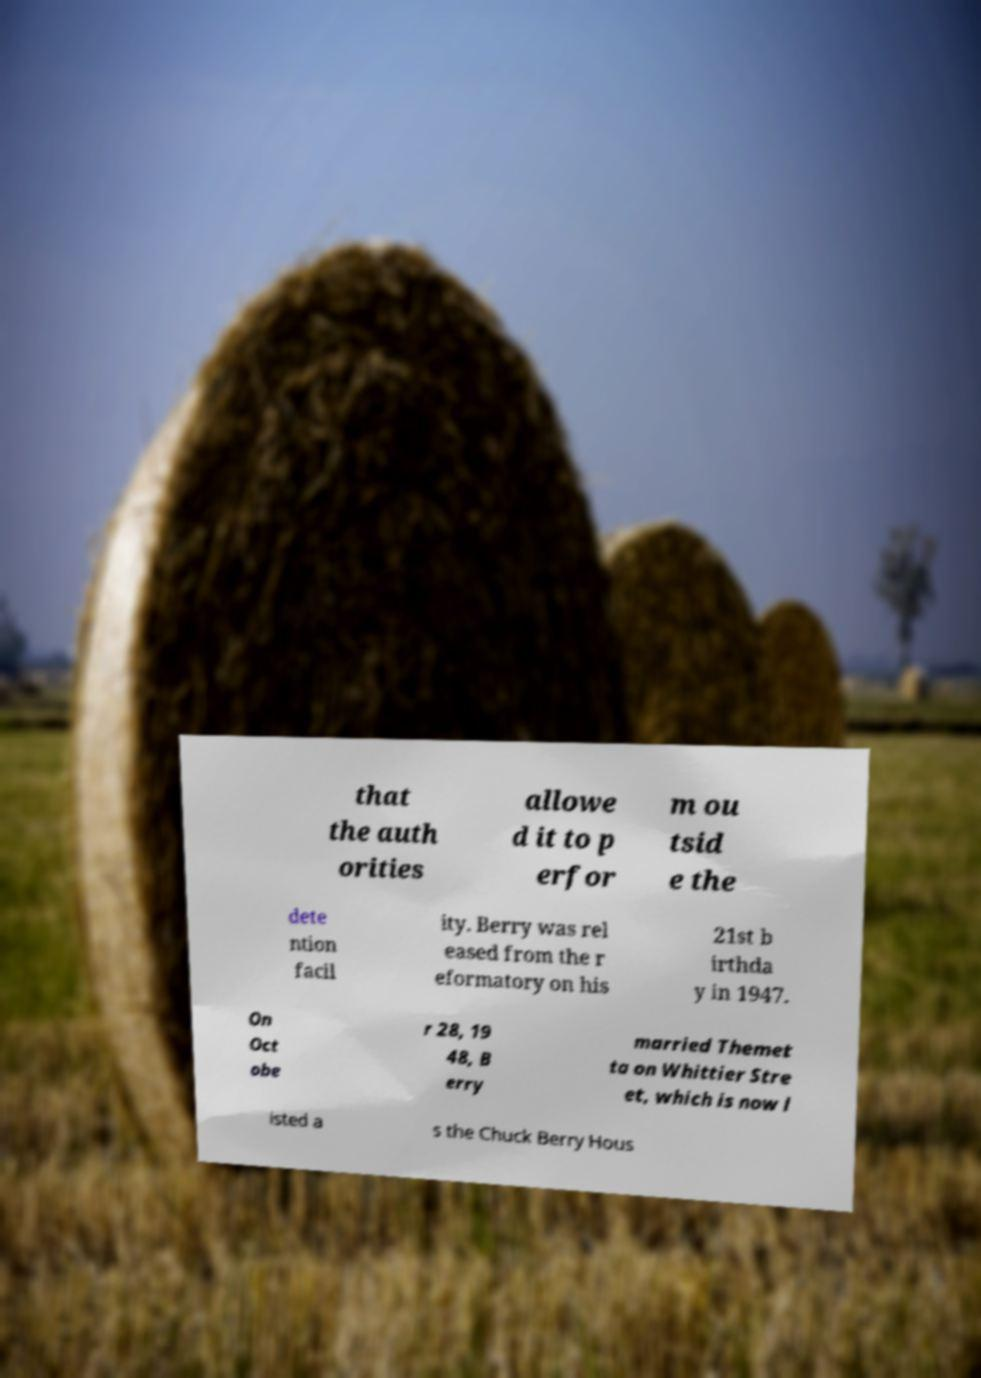What messages or text are displayed in this image? I need them in a readable, typed format. that the auth orities allowe d it to p erfor m ou tsid e the dete ntion facil ity. Berry was rel eased from the r eformatory on his 21st b irthda y in 1947. On Oct obe r 28, 19 48, B erry married Themet ta on Whittier Stre et, which is now l isted a s the Chuck Berry Hous 